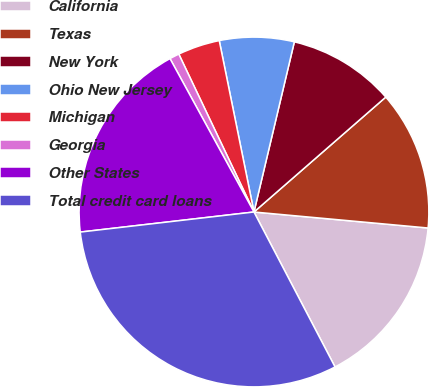Convert chart to OTSL. <chart><loc_0><loc_0><loc_500><loc_500><pie_chart><fcel>California<fcel>Texas<fcel>New York<fcel>Ohio New Jersey<fcel>Michigan<fcel>Georgia<fcel>Other States<fcel>Total credit card loans<nl><fcel>15.87%<fcel>12.87%<fcel>9.88%<fcel>6.89%<fcel>3.89%<fcel>0.9%<fcel>18.86%<fcel>30.84%<nl></chart> 